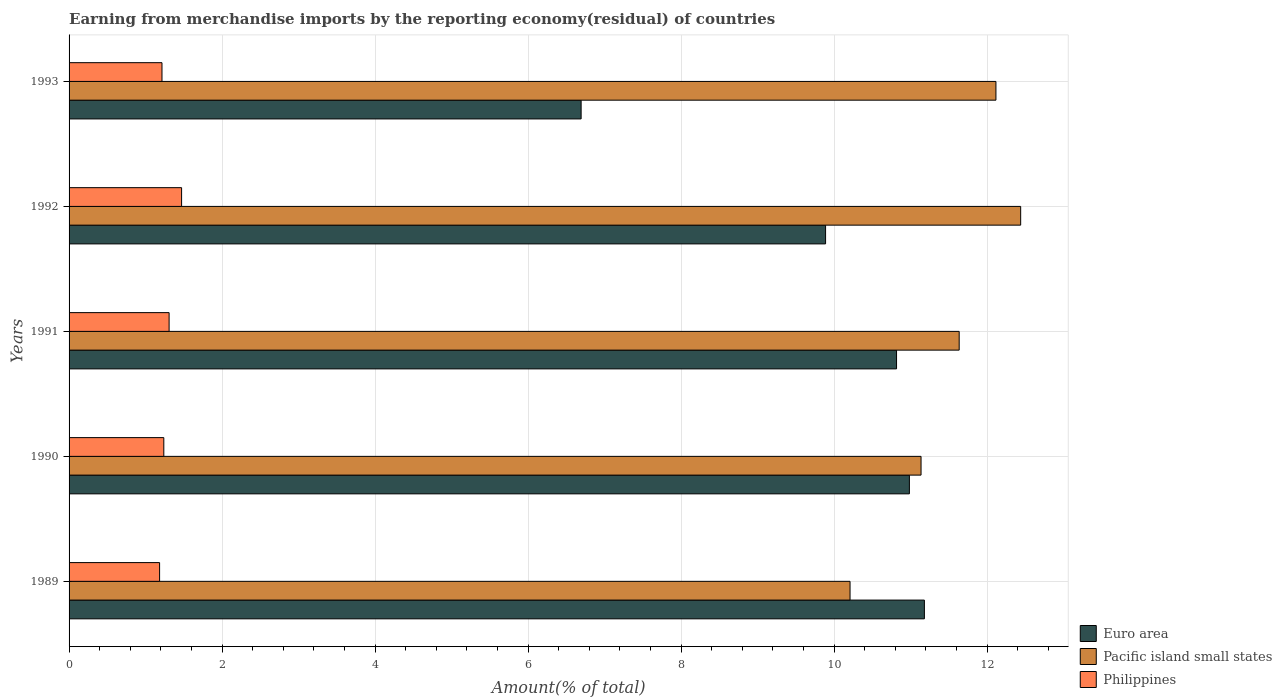How many different coloured bars are there?
Provide a short and direct response. 3. How many groups of bars are there?
Offer a very short reply. 5. Are the number of bars per tick equal to the number of legend labels?
Your answer should be compact. Yes. Are the number of bars on each tick of the Y-axis equal?
Your answer should be very brief. Yes. How many bars are there on the 2nd tick from the bottom?
Your answer should be very brief. 3. What is the percentage of amount earned from merchandise imports in Euro area in 1992?
Give a very brief answer. 9.89. Across all years, what is the maximum percentage of amount earned from merchandise imports in Pacific island small states?
Offer a terse response. 12.44. Across all years, what is the minimum percentage of amount earned from merchandise imports in Philippines?
Ensure brevity in your answer.  1.18. In which year was the percentage of amount earned from merchandise imports in Pacific island small states minimum?
Make the answer very short. 1989. What is the total percentage of amount earned from merchandise imports in Euro area in the graph?
Your answer should be very brief. 49.57. What is the difference between the percentage of amount earned from merchandise imports in Euro area in 1992 and that in 1993?
Offer a very short reply. 3.2. What is the difference between the percentage of amount earned from merchandise imports in Pacific island small states in 1993 and the percentage of amount earned from merchandise imports in Euro area in 1989?
Make the answer very short. 0.94. What is the average percentage of amount earned from merchandise imports in Pacific island small states per year?
Make the answer very short. 11.51. In the year 1991, what is the difference between the percentage of amount earned from merchandise imports in Pacific island small states and percentage of amount earned from merchandise imports in Euro area?
Offer a very short reply. 0.82. What is the ratio of the percentage of amount earned from merchandise imports in Philippines in 1991 to that in 1993?
Give a very brief answer. 1.08. Is the percentage of amount earned from merchandise imports in Euro area in 1992 less than that in 1993?
Keep it short and to the point. No. Is the difference between the percentage of amount earned from merchandise imports in Pacific island small states in 1989 and 1990 greater than the difference between the percentage of amount earned from merchandise imports in Euro area in 1989 and 1990?
Ensure brevity in your answer.  No. What is the difference between the highest and the second highest percentage of amount earned from merchandise imports in Philippines?
Your answer should be very brief. 0.16. What is the difference between the highest and the lowest percentage of amount earned from merchandise imports in Philippines?
Your answer should be very brief. 0.29. In how many years, is the percentage of amount earned from merchandise imports in Pacific island small states greater than the average percentage of amount earned from merchandise imports in Pacific island small states taken over all years?
Ensure brevity in your answer.  3. What does the 2nd bar from the top in 1993 represents?
Ensure brevity in your answer.  Pacific island small states. What does the 3rd bar from the bottom in 1991 represents?
Your response must be concise. Philippines. What is the difference between two consecutive major ticks on the X-axis?
Your answer should be compact. 2. Are the values on the major ticks of X-axis written in scientific E-notation?
Ensure brevity in your answer.  No. Does the graph contain any zero values?
Provide a short and direct response. No. Does the graph contain grids?
Your response must be concise. Yes. How many legend labels are there?
Make the answer very short. 3. What is the title of the graph?
Provide a succinct answer. Earning from merchandise imports by the reporting economy(residual) of countries. What is the label or title of the X-axis?
Offer a very short reply. Amount(% of total). What is the Amount(% of total) of Euro area in 1989?
Give a very brief answer. 11.18. What is the Amount(% of total) of Pacific island small states in 1989?
Provide a short and direct response. 10.21. What is the Amount(% of total) in Philippines in 1989?
Provide a succinct answer. 1.18. What is the Amount(% of total) in Euro area in 1990?
Make the answer very short. 10.99. What is the Amount(% of total) in Pacific island small states in 1990?
Make the answer very short. 11.14. What is the Amount(% of total) in Philippines in 1990?
Provide a short and direct response. 1.24. What is the Amount(% of total) in Euro area in 1991?
Give a very brief answer. 10.82. What is the Amount(% of total) of Pacific island small states in 1991?
Your answer should be compact. 11.64. What is the Amount(% of total) in Philippines in 1991?
Offer a very short reply. 1.31. What is the Amount(% of total) of Euro area in 1992?
Provide a succinct answer. 9.89. What is the Amount(% of total) of Pacific island small states in 1992?
Give a very brief answer. 12.44. What is the Amount(% of total) in Philippines in 1992?
Your response must be concise. 1.47. What is the Amount(% of total) in Euro area in 1993?
Keep it short and to the point. 6.69. What is the Amount(% of total) of Pacific island small states in 1993?
Provide a short and direct response. 12.12. What is the Amount(% of total) in Philippines in 1993?
Give a very brief answer. 1.21. Across all years, what is the maximum Amount(% of total) of Euro area?
Your answer should be compact. 11.18. Across all years, what is the maximum Amount(% of total) of Pacific island small states?
Provide a short and direct response. 12.44. Across all years, what is the maximum Amount(% of total) in Philippines?
Offer a very short reply. 1.47. Across all years, what is the minimum Amount(% of total) in Euro area?
Your response must be concise. 6.69. Across all years, what is the minimum Amount(% of total) of Pacific island small states?
Provide a succinct answer. 10.21. Across all years, what is the minimum Amount(% of total) in Philippines?
Your response must be concise. 1.18. What is the total Amount(% of total) of Euro area in the graph?
Offer a very short reply. 49.57. What is the total Amount(% of total) of Pacific island small states in the graph?
Offer a terse response. 57.54. What is the total Amount(% of total) of Philippines in the graph?
Provide a short and direct response. 6.42. What is the difference between the Amount(% of total) in Euro area in 1989 and that in 1990?
Ensure brevity in your answer.  0.2. What is the difference between the Amount(% of total) of Pacific island small states in 1989 and that in 1990?
Your response must be concise. -0.93. What is the difference between the Amount(% of total) in Philippines in 1989 and that in 1990?
Your answer should be very brief. -0.06. What is the difference between the Amount(% of total) in Euro area in 1989 and that in 1991?
Offer a terse response. 0.36. What is the difference between the Amount(% of total) of Pacific island small states in 1989 and that in 1991?
Keep it short and to the point. -1.43. What is the difference between the Amount(% of total) in Philippines in 1989 and that in 1991?
Make the answer very short. -0.12. What is the difference between the Amount(% of total) of Euro area in 1989 and that in 1992?
Make the answer very short. 1.29. What is the difference between the Amount(% of total) of Pacific island small states in 1989 and that in 1992?
Offer a very short reply. -2.23. What is the difference between the Amount(% of total) of Philippines in 1989 and that in 1992?
Give a very brief answer. -0.29. What is the difference between the Amount(% of total) in Euro area in 1989 and that in 1993?
Provide a succinct answer. 4.49. What is the difference between the Amount(% of total) of Pacific island small states in 1989 and that in 1993?
Offer a very short reply. -1.91. What is the difference between the Amount(% of total) of Philippines in 1989 and that in 1993?
Provide a short and direct response. -0.03. What is the difference between the Amount(% of total) of Euro area in 1990 and that in 1991?
Keep it short and to the point. 0.17. What is the difference between the Amount(% of total) of Pacific island small states in 1990 and that in 1991?
Offer a very short reply. -0.5. What is the difference between the Amount(% of total) in Philippines in 1990 and that in 1991?
Make the answer very short. -0.07. What is the difference between the Amount(% of total) of Euro area in 1990 and that in 1992?
Offer a very short reply. 1.1. What is the difference between the Amount(% of total) in Pacific island small states in 1990 and that in 1992?
Your response must be concise. -1.3. What is the difference between the Amount(% of total) in Philippines in 1990 and that in 1992?
Keep it short and to the point. -0.23. What is the difference between the Amount(% of total) in Euro area in 1990 and that in 1993?
Your answer should be compact. 4.29. What is the difference between the Amount(% of total) in Pacific island small states in 1990 and that in 1993?
Your response must be concise. -0.98. What is the difference between the Amount(% of total) in Philippines in 1990 and that in 1993?
Provide a short and direct response. 0.02. What is the difference between the Amount(% of total) in Euro area in 1991 and that in 1992?
Provide a short and direct response. 0.93. What is the difference between the Amount(% of total) of Pacific island small states in 1991 and that in 1992?
Give a very brief answer. -0.8. What is the difference between the Amount(% of total) of Philippines in 1991 and that in 1992?
Your answer should be compact. -0.16. What is the difference between the Amount(% of total) in Euro area in 1991 and that in 1993?
Keep it short and to the point. 4.12. What is the difference between the Amount(% of total) of Pacific island small states in 1991 and that in 1993?
Offer a very short reply. -0.48. What is the difference between the Amount(% of total) in Philippines in 1991 and that in 1993?
Keep it short and to the point. 0.09. What is the difference between the Amount(% of total) of Euro area in 1992 and that in 1993?
Provide a short and direct response. 3.2. What is the difference between the Amount(% of total) in Pacific island small states in 1992 and that in 1993?
Offer a very short reply. 0.32. What is the difference between the Amount(% of total) in Philippines in 1992 and that in 1993?
Provide a succinct answer. 0.26. What is the difference between the Amount(% of total) in Euro area in 1989 and the Amount(% of total) in Pacific island small states in 1990?
Keep it short and to the point. 0.04. What is the difference between the Amount(% of total) in Euro area in 1989 and the Amount(% of total) in Philippines in 1990?
Ensure brevity in your answer.  9.94. What is the difference between the Amount(% of total) of Pacific island small states in 1989 and the Amount(% of total) of Philippines in 1990?
Give a very brief answer. 8.97. What is the difference between the Amount(% of total) of Euro area in 1989 and the Amount(% of total) of Pacific island small states in 1991?
Provide a short and direct response. -0.46. What is the difference between the Amount(% of total) in Euro area in 1989 and the Amount(% of total) in Philippines in 1991?
Keep it short and to the point. 9.87. What is the difference between the Amount(% of total) of Pacific island small states in 1989 and the Amount(% of total) of Philippines in 1991?
Make the answer very short. 8.9. What is the difference between the Amount(% of total) of Euro area in 1989 and the Amount(% of total) of Pacific island small states in 1992?
Offer a very short reply. -1.26. What is the difference between the Amount(% of total) in Euro area in 1989 and the Amount(% of total) in Philippines in 1992?
Offer a terse response. 9.71. What is the difference between the Amount(% of total) of Pacific island small states in 1989 and the Amount(% of total) of Philippines in 1992?
Provide a succinct answer. 8.74. What is the difference between the Amount(% of total) in Euro area in 1989 and the Amount(% of total) in Pacific island small states in 1993?
Offer a very short reply. -0.94. What is the difference between the Amount(% of total) of Euro area in 1989 and the Amount(% of total) of Philippines in 1993?
Offer a very short reply. 9.97. What is the difference between the Amount(% of total) of Pacific island small states in 1989 and the Amount(% of total) of Philippines in 1993?
Make the answer very short. 8.99. What is the difference between the Amount(% of total) of Euro area in 1990 and the Amount(% of total) of Pacific island small states in 1991?
Ensure brevity in your answer.  -0.65. What is the difference between the Amount(% of total) in Euro area in 1990 and the Amount(% of total) in Philippines in 1991?
Your answer should be very brief. 9.68. What is the difference between the Amount(% of total) in Pacific island small states in 1990 and the Amount(% of total) in Philippines in 1991?
Your answer should be very brief. 9.83. What is the difference between the Amount(% of total) in Euro area in 1990 and the Amount(% of total) in Pacific island small states in 1992?
Offer a terse response. -1.45. What is the difference between the Amount(% of total) in Euro area in 1990 and the Amount(% of total) in Philippines in 1992?
Give a very brief answer. 9.51. What is the difference between the Amount(% of total) in Pacific island small states in 1990 and the Amount(% of total) in Philippines in 1992?
Give a very brief answer. 9.67. What is the difference between the Amount(% of total) of Euro area in 1990 and the Amount(% of total) of Pacific island small states in 1993?
Your response must be concise. -1.13. What is the difference between the Amount(% of total) of Euro area in 1990 and the Amount(% of total) of Philippines in 1993?
Make the answer very short. 9.77. What is the difference between the Amount(% of total) in Pacific island small states in 1990 and the Amount(% of total) in Philippines in 1993?
Your answer should be very brief. 9.92. What is the difference between the Amount(% of total) in Euro area in 1991 and the Amount(% of total) in Pacific island small states in 1992?
Offer a terse response. -1.62. What is the difference between the Amount(% of total) in Euro area in 1991 and the Amount(% of total) in Philippines in 1992?
Your response must be concise. 9.35. What is the difference between the Amount(% of total) in Pacific island small states in 1991 and the Amount(% of total) in Philippines in 1992?
Offer a terse response. 10.17. What is the difference between the Amount(% of total) in Euro area in 1991 and the Amount(% of total) in Pacific island small states in 1993?
Offer a very short reply. -1.3. What is the difference between the Amount(% of total) in Euro area in 1991 and the Amount(% of total) in Philippines in 1993?
Ensure brevity in your answer.  9.6. What is the difference between the Amount(% of total) of Pacific island small states in 1991 and the Amount(% of total) of Philippines in 1993?
Provide a succinct answer. 10.42. What is the difference between the Amount(% of total) in Euro area in 1992 and the Amount(% of total) in Pacific island small states in 1993?
Make the answer very short. -2.23. What is the difference between the Amount(% of total) in Euro area in 1992 and the Amount(% of total) in Philippines in 1993?
Provide a short and direct response. 8.68. What is the difference between the Amount(% of total) of Pacific island small states in 1992 and the Amount(% of total) of Philippines in 1993?
Ensure brevity in your answer.  11.23. What is the average Amount(% of total) in Euro area per year?
Keep it short and to the point. 9.91. What is the average Amount(% of total) of Pacific island small states per year?
Provide a succinct answer. 11.51. What is the average Amount(% of total) of Philippines per year?
Ensure brevity in your answer.  1.28. In the year 1989, what is the difference between the Amount(% of total) in Euro area and Amount(% of total) in Philippines?
Keep it short and to the point. 10. In the year 1989, what is the difference between the Amount(% of total) of Pacific island small states and Amount(% of total) of Philippines?
Your response must be concise. 9.03. In the year 1990, what is the difference between the Amount(% of total) in Euro area and Amount(% of total) in Pacific island small states?
Give a very brief answer. -0.15. In the year 1990, what is the difference between the Amount(% of total) in Euro area and Amount(% of total) in Philippines?
Offer a very short reply. 9.75. In the year 1990, what is the difference between the Amount(% of total) in Pacific island small states and Amount(% of total) in Philippines?
Give a very brief answer. 9.9. In the year 1991, what is the difference between the Amount(% of total) in Euro area and Amount(% of total) in Pacific island small states?
Your response must be concise. -0.82. In the year 1991, what is the difference between the Amount(% of total) of Euro area and Amount(% of total) of Philippines?
Your response must be concise. 9.51. In the year 1991, what is the difference between the Amount(% of total) of Pacific island small states and Amount(% of total) of Philippines?
Ensure brevity in your answer.  10.33. In the year 1992, what is the difference between the Amount(% of total) in Euro area and Amount(% of total) in Pacific island small states?
Keep it short and to the point. -2.55. In the year 1992, what is the difference between the Amount(% of total) in Euro area and Amount(% of total) in Philippines?
Give a very brief answer. 8.42. In the year 1992, what is the difference between the Amount(% of total) of Pacific island small states and Amount(% of total) of Philippines?
Keep it short and to the point. 10.97. In the year 1993, what is the difference between the Amount(% of total) in Euro area and Amount(% of total) in Pacific island small states?
Give a very brief answer. -5.42. In the year 1993, what is the difference between the Amount(% of total) in Euro area and Amount(% of total) in Philippines?
Offer a very short reply. 5.48. In the year 1993, what is the difference between the Amount(% of total) in Pacific island small states and Amount(% of total) in Philippines?
Offer a very short reply. 10.9. What is the ratio of the Amount(% of total) in Euro area in 1989 to that in 1990?
Give a very brief answer. 1.02. What is the ratio of the Amount(% of total) in Pacific island small states in 1989 to that in 1990?
Provide a short and direct response. 0.92. What is the ratio of the Amount(% of total) in Philippines in 1989 to that in 1990?
Provide a succinct answer. 0.96. What is the ratio of the Amount(% of total) in Euro area in 1989 to that in 1991?
Your answer should be compact. 1.03. What is the ratio of the Amount(% of total) of Pacific island small states in 1989 to that in 1991?
Ensure brevity in your answer.  0.88. What is the ratio of the Amount(% of total) in Philippines in 1989 to that in 1991?
Give a very brief answer. 0.91. What is the ratio of the Amount(% of total) in Euro area in 1989 to that in 1992?
Keep it short and to the point. 1.13. What is the ratio of the Amount(% of total) of Pacific island small states in 1989 to that in 1992?
Offer a terse response. 0.82. What is the ratio of the Amount(% of total) of Philippines in 1989 to that in 1992?
Give a very brief answer. 0.8. What is the ratio of the Amount(% of total) of Euro area in 1989 to that in 1993?
Your response must be concise. 1.67. What is the ratio of the Amount(% of total) of Pacific island small states in 1989 to that in 1993?
Your response must be concise. 0.84. What is the ratio of the Amount(% of total) in Philippines in 1989 to that in 1993?
Your response must be concise. 0.97. What is the ratio of the Amount(% of total) in Euro area in 1990 to that in 1991?
Ensure brevity in your answer.  1.02. What is the ratio of the Amount(% of total) of Pacific island small states in 1990 to that in 1991?
Ensure brevity in your answer.  0.96. What is the ratio of the Amount(% of total) in Philippines in 1990 to that in 1991?
Provide a succinct answer. 0.95. What is the ratio of the Amount(% of total) of Euro area in 1990 to that in 1992?
Offer a terse response. 1.11. What is the ratio of the Amount(% of total) of Pacific island small states in 1990 to that in 1992?
Provide a short and direct response. 0.9. What is the ratio of the Amount(% of total) of Philippines in 1990 to that in 1992?
Your answer should be very brief. 0.84. What is the ratio of the Amount(% of total) of Euro area in 1990 to that in 1993?
Offer a very short reply. 1.64. What is the ratio of the Amount(% of total) in Pacific island small states in 1990 to that in 1993?
Your response must be concise. 0.92. What is the ratio of the Amount(% of total) of Philippines in 1990 to that in 1993?
Provide a succinct answer. 1.02. What is the ratio of the Amount(% of total) in Euro area in 1991 to that in 1992?
Provide a succinct answer. 1.09. What is the ratio of the Amount(% of total) in Pacific island small states in 1991 to that in 1992?
Your response must be concise. 0.94. What is the ratio of the Amount(% of total) in Philippines in 1991 to that in 1992?
Ensure brevity in your answer.  0.89. What is the ratio of the Amount(% of total) in Euro area in 1991 to that in 1993?
Make the answer very short. 1.62. What is the ratio of the Amount(% of total) of Pacific island small states in 1991 to that in 1993?
Your response must be concise. 0.96. What is the ratio of the Amount(% of total) in Philippines in 1991 to that in 1993?
Keep it short and to the point. 1.08. What is the ratio of the Amount(% of total) in Euro area in 1992 to that in 1993?
Give a very brief answer. 1.48. What is the ratio of the Amount(% of total) of Pacific island small states in 1992 to that in 1993?
Make the answer very short. 1.03. What is the ratio of the Amount(% of total) of Philippines in 1992 to that in 1993?
Provide a short and direct response. 1.21. What is the difference between the highest and the second highest Amount(% of total) of Euro area?
Your response must be concise. 0.2. What is the difference between the highest and the second highest Amount(% of total) of Pacific island small states?
Provide a short and direct response. 0.32. What is the difference between the highest and the second highest Amount(% of total) of Philippines?
Offer a terse response. 0.16. What is the difference between the highest and the lowest Amount(% of total) in Euro area?
Provide a succinct answer. 4.49. What is the difference between the highest and the lowest Amount(% of total) in Pacific island small states?
Ensure brevity in your answer.  2.23. What is the difference between the highest and the lowest Amount(% of total) of Philippines?
Your answer should be very brief. 0.29. 